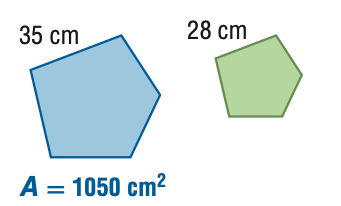Question: For the pair of similar figures, find the area of the green figure.
Choices:
A. 672
B. 840
C. 1313
D. 1641
Answer with the letter. Answer: A 